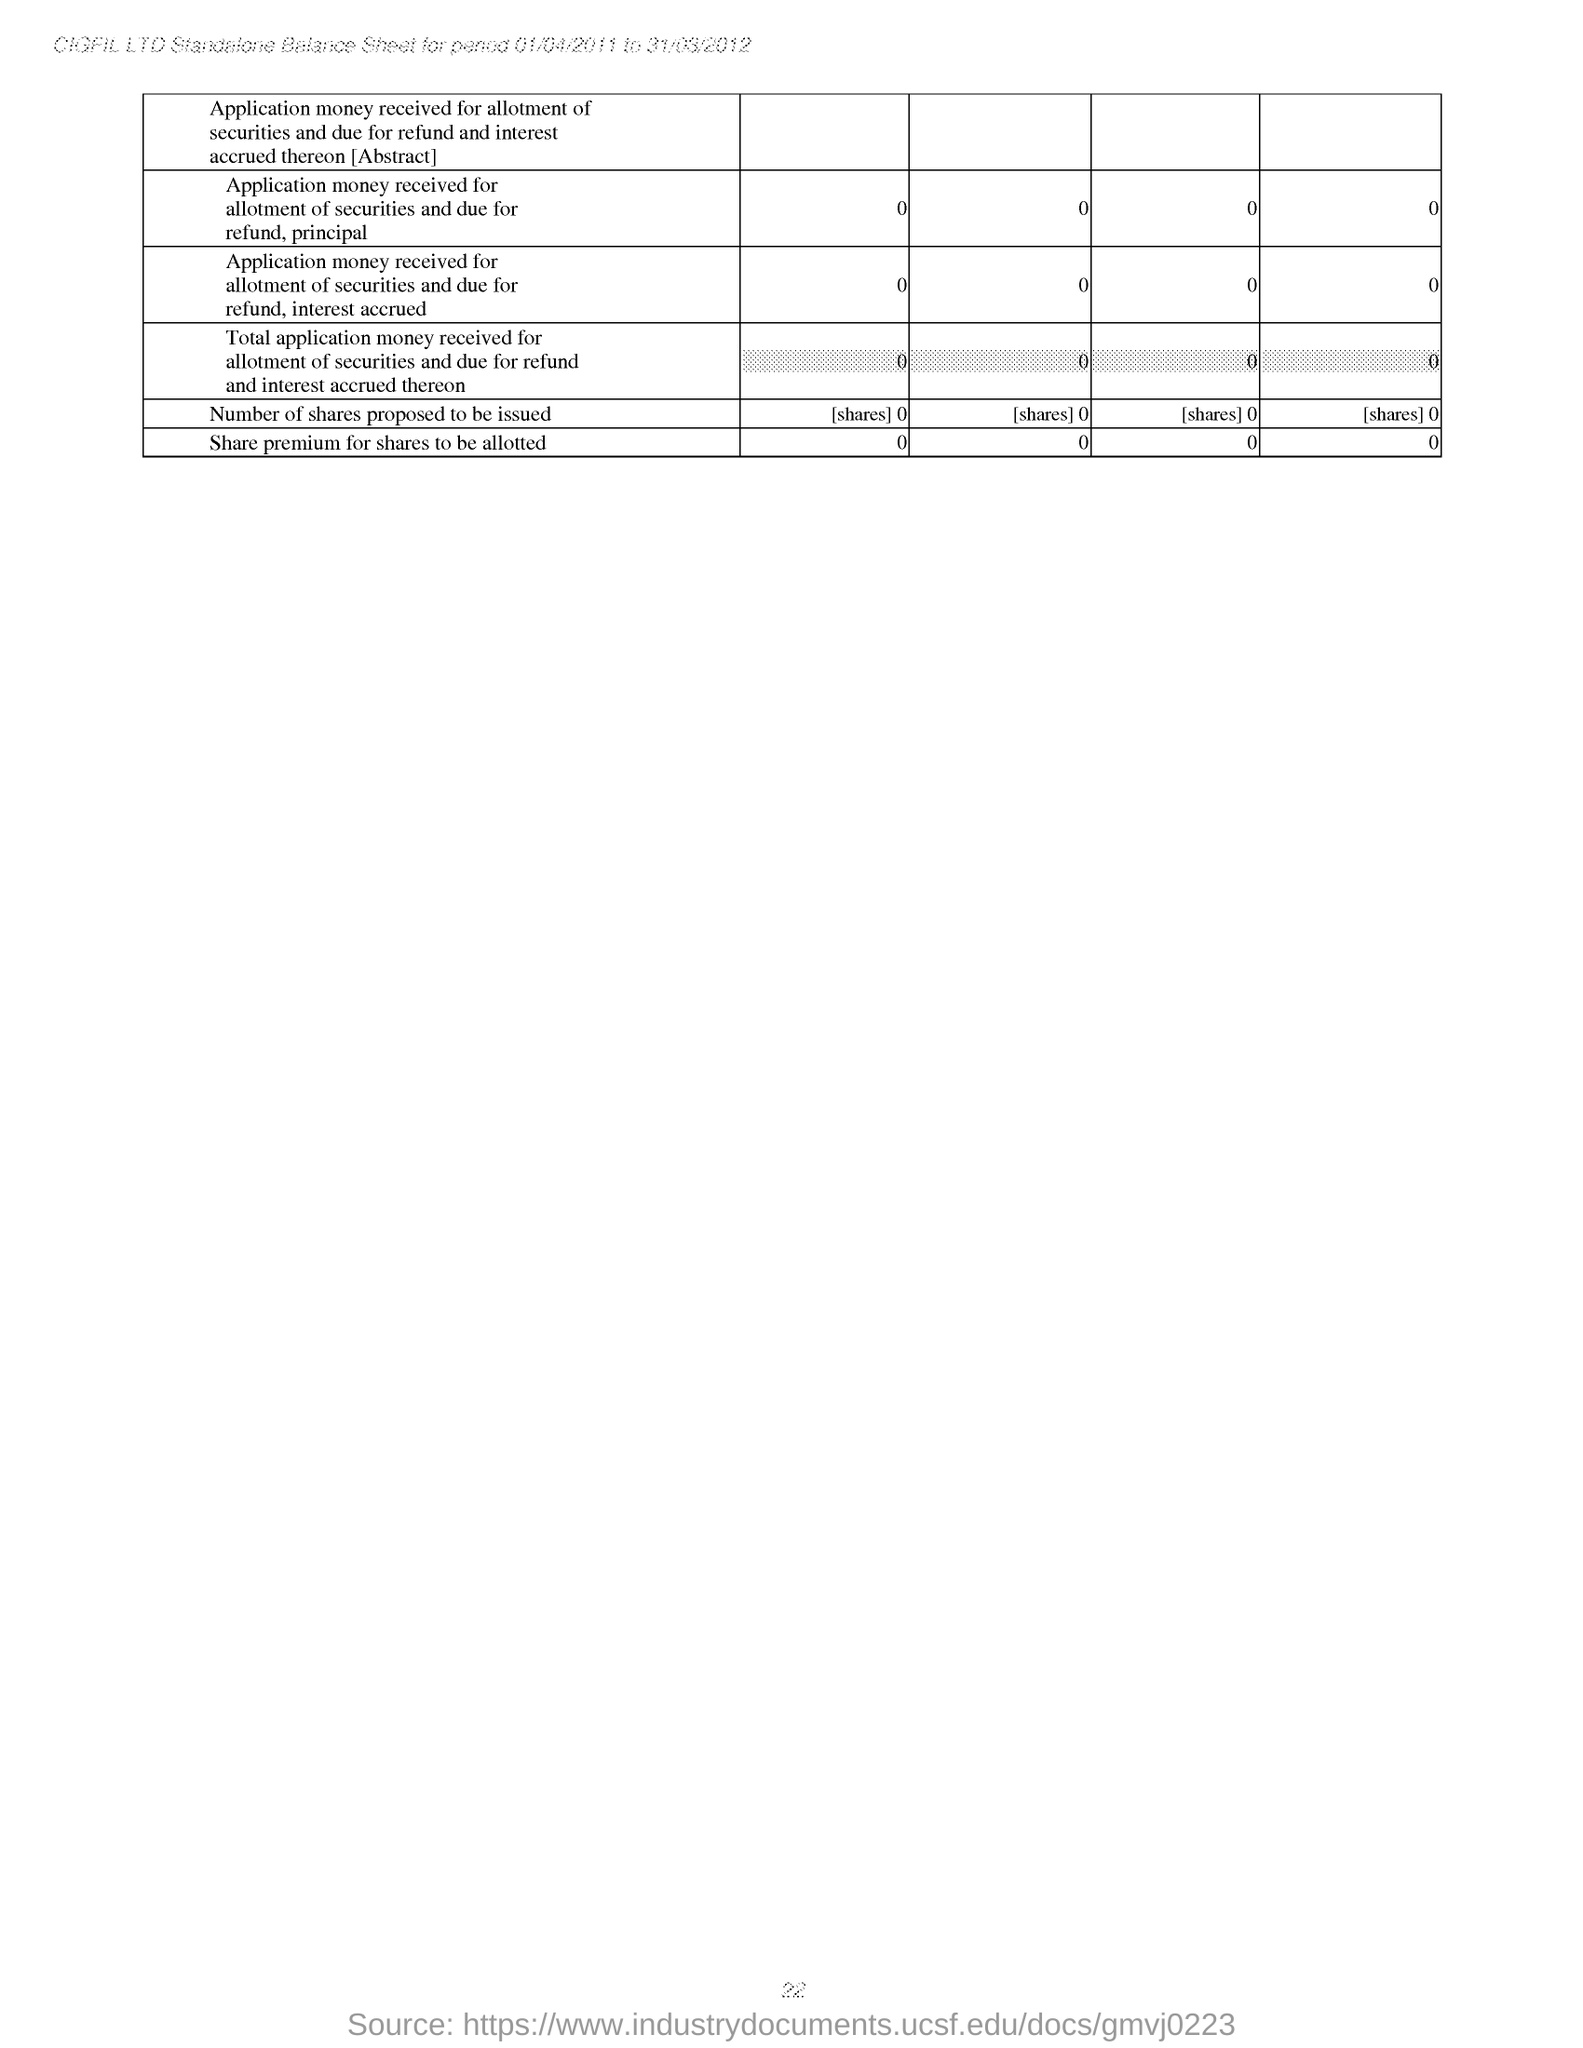Identify some key points in this picture. The company name specified in the header of the document is CIGFIL LTD. The Standalone Balance Sheet for the period of 01/04/2011 to 31/03/2012 is mentioned in the header of the document. 